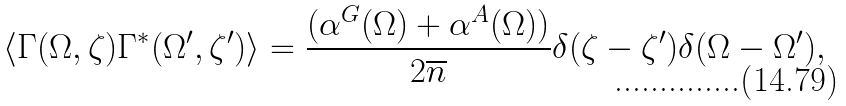<formula> <loc_0><loc_0><loc_500><loc_500>\langle \Gamma ( \Omega , \zeta ) \Gamma ^ { * } ( \Omega ^ { \prime } , \zeta ^ { \prime } ) \rangle = \frac { ( \alpha ^ { G } ( \Omega ) + \alpha ^ { A } ( \Omega ) ) } { 2 \overline { n } } \delta ( \zeta - \zeta ^ { \prime } ) \delta ( \Omega - \Omega ^ { \prime } ) ,</formula> 